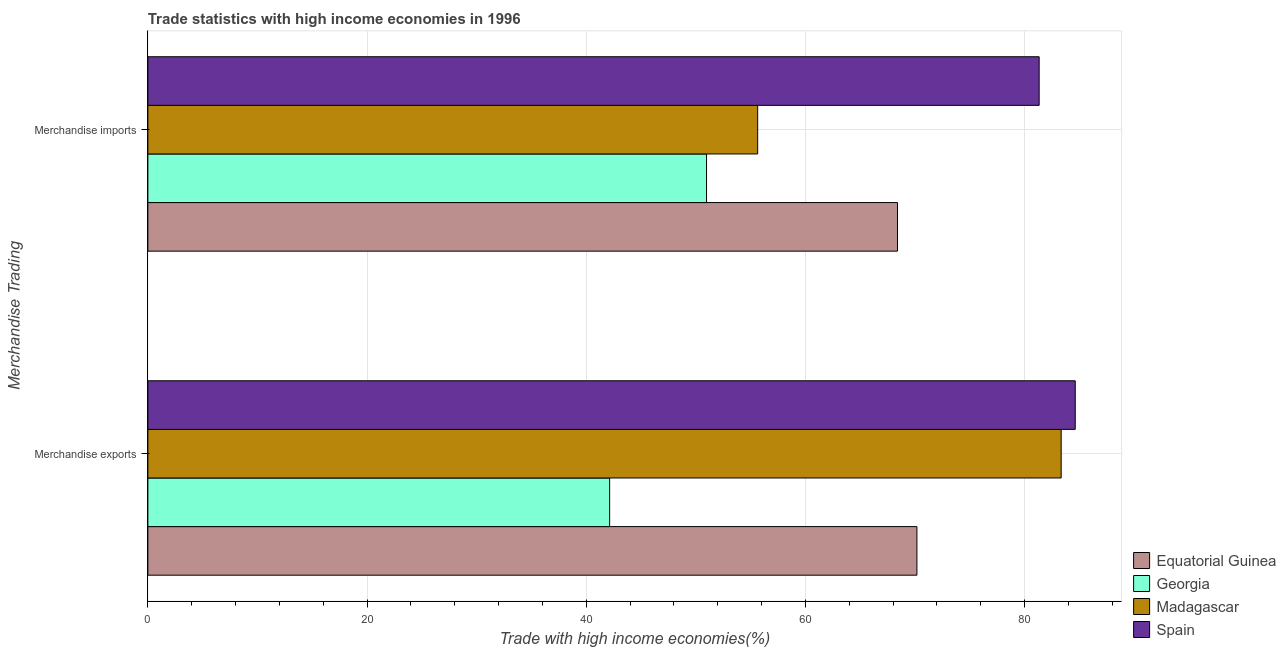How many groups of bars are there?
Offer a terse response. 2. How many bars are there on the 2nd tick from the bottom?
Make the answer very short. 4. What is the merchandise imports in Spain?
Offer a terse response. 81.33. Across all countries, what is the maximum merchandise imports?
Ensure brevity in your answer.  81.33. Across all countries, what is the minimum merchandise imports?
Ensure brevity in your answer.  50.98. In which country was the merchandise imports minimum?
Make the answer very short. Georgia. What is the total merchandise imports in the graph?
Provide a short and direct response. 256.37. What is the difference between the merchandise imports in Equatorial Guinea and that in Madagascar?
Give a very brief answer. 12.76. What is the difference between the merchandise exports in Equatorial Guinea and the merchandise imports in Madagascar?
Offer a very short reply. 14.53. What is the average merchandise exports per country?
Provide a succinct answer. 70.07. What is the difference between the merchandise imports and merchandise exports in Madagascar?
Offer a terse response. -27.7. What is the ratio of the merchandise exports in Georgia to that in Madagascar?
Your answer should be very brief. 0.51. Is the merchandise imports in Georgia less than that in Spain?
Keep it short and to the point. Yes. What does the 1st bar from the top in Merchandise imports represents?
Your answer should be very brief. Spain. What does the 3rd bar from the bottom in Merchandise exports represents?
Your answer should be very brief. Madagascar. Are all the bars in the graph horizontal?
Provide a succinct answer. Yes. How are the legend labels stacked?
Offer a very short reply. Vertical. What is the title of the graph?
Offer a terse response. Trade statistics with high income economies in 1996. What is the label or title of the X-axis?
Offer a very short reply. Trade with high income economies(%). What is the label or title of the Y-axis?
Provide a short and direct response. Merchandise Trading. What is the Trade with high income economies(%) in Equatorial Guinea in Merchandise exports?
Your response must be concise. 70.18. What is the Trade with high income economies(%) in Georgia in Merchandise exports?
Provide a short and direct response. 42.14. What is the Trade with high income economies(%) of Madagascar in Merchandise exports?
Your answer should be compact. 83.34. What is the Trade with high income economies(%) in Spain in Merchandise exports?
Give a very brief answer. 84.63. What is the Trade with high income economies(%) of Equatorial Guinea in Merchandise imports?
Ensure brevity in your answer.  68.41. What is the Trade with high income economies(%) of Georgia in Merchandise imports?
Your answer should be very brief. 50.98. What is the Trade with high income economies(%) of Madagascar in Merchandise imports?
Provide a short and direct response. 55.65. What is the Trade with high income economies(%) in Spain in Merchandise imports?
Provide a succinct answer. 81.33. Across all Merchandise Trading, what is the maximum Trade with high income economies(%) of Equatorial Guinea?
Make the answer very short. 70.18. Across all Merchandise Trading, what is the maximum Trade with high income economies(%) in Georgia?
Your answer should be compact. 50.98. Across all Merchandise Trading, what is the maximum Trade with high income economies(%) of Madagascar?
Provide a short and direct response. 83.34. Across all Merchandise Trading, what is the maximum Trade with high income economies(%) of Spain?
Provide a short and direct response. 84.63. Across all Merchandise Trading, what is the minimum Trade with high income economies(%) of Equatorial Guinea?
Offer a terse response. 68.41. Across all Merchandise Trading, what is the minimum Trade with high income economies(%) of Georgia?
Give a very brief answer. 42.14. Across all Merchandise Trading, what is the minimum Trade with high income economies(%) of Madagascar?
Provide a short and direct response. 55.65. Across all Merchandise Trading, what is the minimum Trade with high income economies(%) of Spain?
Ensure brevity in your answer.  81.33. What is the total Trade with high income economies(%) in Equatorial Guinea in the graph?
Offer a very short reply. 138.59. What is the total Trade with high income economies(%) in Georgia in the graph?
Give a very brief answer. 93.12. What is the total Trade with high income economies(%) in Madagascar in the graph?
Your response must be concise. 138.99. What is the total Trade with high income economies(%) in Spain in the graph?
Your answer should be compact. 165.96. What is the difference between the Trade with high income economies(%) in Equatorial Guinea in Merchandise exports and that in Merchandise imports?
Your answer should be compact. 1.77. What is the difference between the Trade with high income economies(%) of Georgia in Merchandise exports and that in Merchandise imports?
Make the answer very short. -8.84. What is the difference between the Trade with high income economies(%) of Madagascar in Merchandise exports and that in Merchandise imports?
Your answer should be compact. 27.7. What is the difference between the Trade with high income economies(%) in Spain in Merchandise exports and that in Merchandise imports?
Provide a short and direct response. 3.29. What is the difference between the Trade with high income economies(%) of Equatorial Guinea in Merchandise exports and the Trade with high income economies(%) of Georgia in Merchandise imports?
Your answer should be very brief. 19.2. What is the difference between the Trade with high income economies(%) of Equatorial Guinea in Merchandise exports and the Trade with high income economies(%) of Madagascar in Merchandise imports?
Your response must be concise. 14.53. What is the difference between the Trade with high income economies(%) in Equatorial Guinea in Merchandise exports and the Trade with high income economies(%) in Spain in Merchandise imports?
Offer a very short reply. -11.15. What is the difference between the Trade with high income economies(%) of Georgia in Merchandise exports and the Trade with high income economies(%) of Madagascar in Merchandise imports?
Keep it short and to the point. -13.51. What is the difference between the Trade with high income economies(%) of Georgia in Merchandise exports and the Trade with high income economies(%) of Spain in Merchandise imports?
Provide a short and direct response. -39.2. What is the difference between the Trade with high income economies(%) of Madagascar in Merchandise exports and the Trade with high income economies(%) of Spain in Merchandise imports?
Ensure brevity in your answer.  2.01. What is the average Trade with high income economies(%) in Equatorial Guinea per Merchandise Trading?
Give a very brief answer. 69.29. What is the average Trade with high income economies(%) of Georgia per Merchandise Trading?
Give a very brief answer. 46.56. What is the average Trade with high income economies(%) of Madagascar per Merchandise Trading?
Your answer should be compact. 69.49. What is the average Trade with high income economies(%) of Spain per Merchandise Trading?
Offer a terse response. 82.98. What is the difference between the Trade with high income economies(%) of Equatorial Guinea and Trade with high income economies(%) of Georgia in Merchandise exports?
Make the answer very short. 28.04. What is the difference between the Trade with high income economies(%) of Equatorial Guinea and Trade with high income economies(%) of Madagascar in Merchandise exports?
Give a very brief answer. -13.16. What is the difference between the Trade with high income economies(%) in Equatorial Guinea and Trade with high income economies(%) in Spain in Merchandise exports?
Your answer should be compact. -14.45. What is the difference between the Trade with high income economies(%) in Georgia and Trade with high income economies(%) in Madagascar in Merchandise exports?
Offer a terse response. -41.2. What is the difference between the Trade with high income economies(%) of Georgia and Trade with high income economies(%) of Spain in Merchandise exports?
Keep it short and to the point. -42.49. What is the difference between the Trade with high income economies(%) in Madagascar and Trade with high income economies(%) in Spain in Merchandise exports?
Make the answer very short. -1.28. What is the difference between the Trade with high income economies(%) in Equatorial Guinea and Trade with high income economies(%) in Georgia in Merchandise imports?
Your answer should be very brief. 17.43. What is the difference between the Trade with high income economies(%) of Equatorial Guinea and Trade with high income economies(%) of Madagascar in Merchandise imports?
Offer a very short reply. 12.76. What is the difference between the Trade with high income economies(%) in Equatorial Guinea and Trade with high income economies(%) in Spain in Merchandise imports?
Make the answer very short. -12.93. What is the difference between the Trade with high income economies(%) in Georgia and Trade with high income economies(%) in Madagascar in Merchandise imports?
Provide a short and direct response. -4.67. What is the difference between the Trade with high income economies(%) of Georgia and Trade with high income economies(%) of Spain in Merchandise imports?
Ensure brevity in your answer.  -30.35. What is the difference between the Trade with high income economies(%) in Madagascar and Trade with high income economies(%) in Spain in Merchandise imports?
Offer a very short reply. -25.69. What is the ratio of the Trade with high income economies(%) in Equatorial Guinea in Merchandise exports to that in Merchandise imports?
Provide a short and direct response. 1.03. What is the ratio of the Trade with high income economies(%) in Georgia in Merchandise exports to that in Merchandise imports?
Your answer should be very brief. 0.83. What is the ratio of the Trade with high income economies(%) in Madagascar in Merchandise exports to that in Merchandise imports?
Your answer should be very brief. 1.5. What is the ratio of the Trade with high income economies(%) of Spain in Merchandise exports to that in Merchandise imports?
Make the answer very short. 1.04. What is the difference between the highest and the second highest Trade with high income economies(%) in Equatorial Guinea?
Your response must be concise. 1.77. What is the difference between the highest and the second highest Trade with high income economies(%) in Georgia?
Ensure brevity in your answer.  8.84. What is the difference between the highest and the second highest Trade with high income economies(%) in Madagascar?
Your response must be concise. 27.7. What is the difference between the highest and the second highest Trade with high income economies(%) of Spain?
Provide a succinct answer. 3.29. What is the difference between the highest and the lowest Trade with high income economies(%) in Equatorial Guinea?
Keep it short and to the point. 1.77. What is the difference between the highest and the lowest Trade with high income economies(%) of Georgia?
Make the answer very short. 8.84. What is the difference between the highest and the lowest Trade with high income economies(%) in Madagascar?
Provide a succinct answer. 27.7. What is the difference between the highest and the lowest Trade with high income economies(%) of Spain?
Provide a short and direct response. 3.29. 